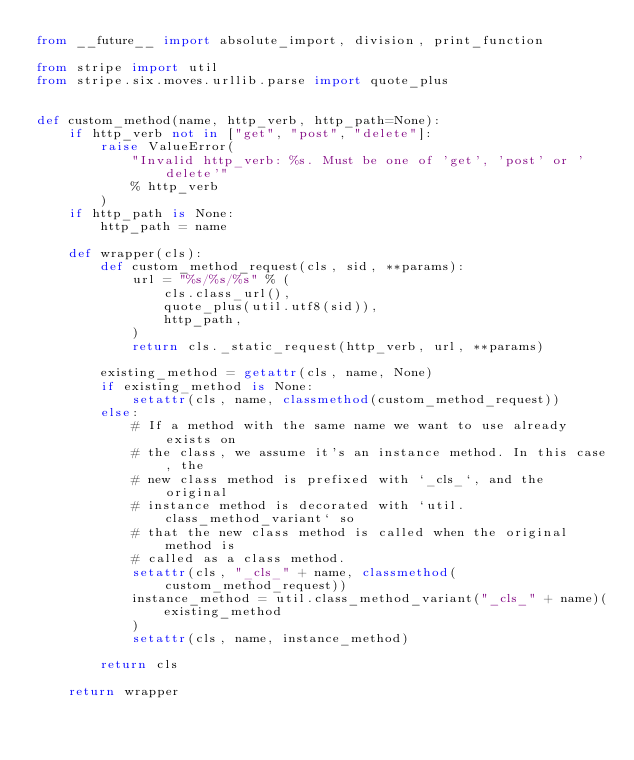Convert code to text. <code><loc_0><loc_0><loc_500><loc_500><_Python_>from __future__ import absolute_import, division, print_function

from stripe import util
from stripe.six.moves.urllib.parse import quote_plus


def custom_method(name, http_verb, http_path=None):
    if http_verb not in ["get", "post", "delete"]:
        raise ValueError(
            "Invalid http_verb: %s. Must be one of 'get', 'post' or 'delete'"
            % http_verb
        )
    if http_path is None:
        http_path = name

    def wrapper(cls):
        def custom_method_request(cls, sid, **params):
            url = "%s/%s/%s" % (
                cls.class_url(),
                quote_plus(util.utf8(sid)),
                http_path,
            )
            return cls._static_request(http_verb, url, **params)

        existing_method = getattr(cls, name, None)
        if existing_method is None:
            setattr(cls, name, classmethod(custom_method_request))
        else:
            # If a method with the same name we want to use already exists on
            # the class, we assume it's an instance method. In this case, the
            # new class method is prefixed with `_cls_`, and the original
            # instance method is decorated with `util.class_method_variant` so
            # that the new class method is called when the original method is
            # called as a class method.
            setattr(cls, "_cls_" + name, classmethod(custom_method_request))
            instance_method = util.class_method_variant("_cls_" + name)(
                existing_method
            )
            setattr(cls, name, instance_method)

        return cls

    return wrapper
</code> 